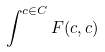Convert formula to latex. <formula><loc_0><loc_0><loc_500><loc_500>\int ^ { c \in C } F ( c , c )</formula> 